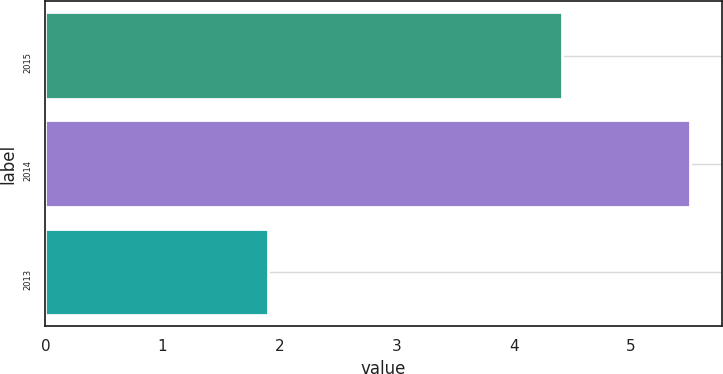Convert chart to OTSL. <chart><loc_0><loc_0><loc_500><loc_500><bar_chart><fcel>2015<fcel>2014<fcel>2013<nl><fcel>4.41<fcel>5.5<fcel>1.9<nl></chart> 